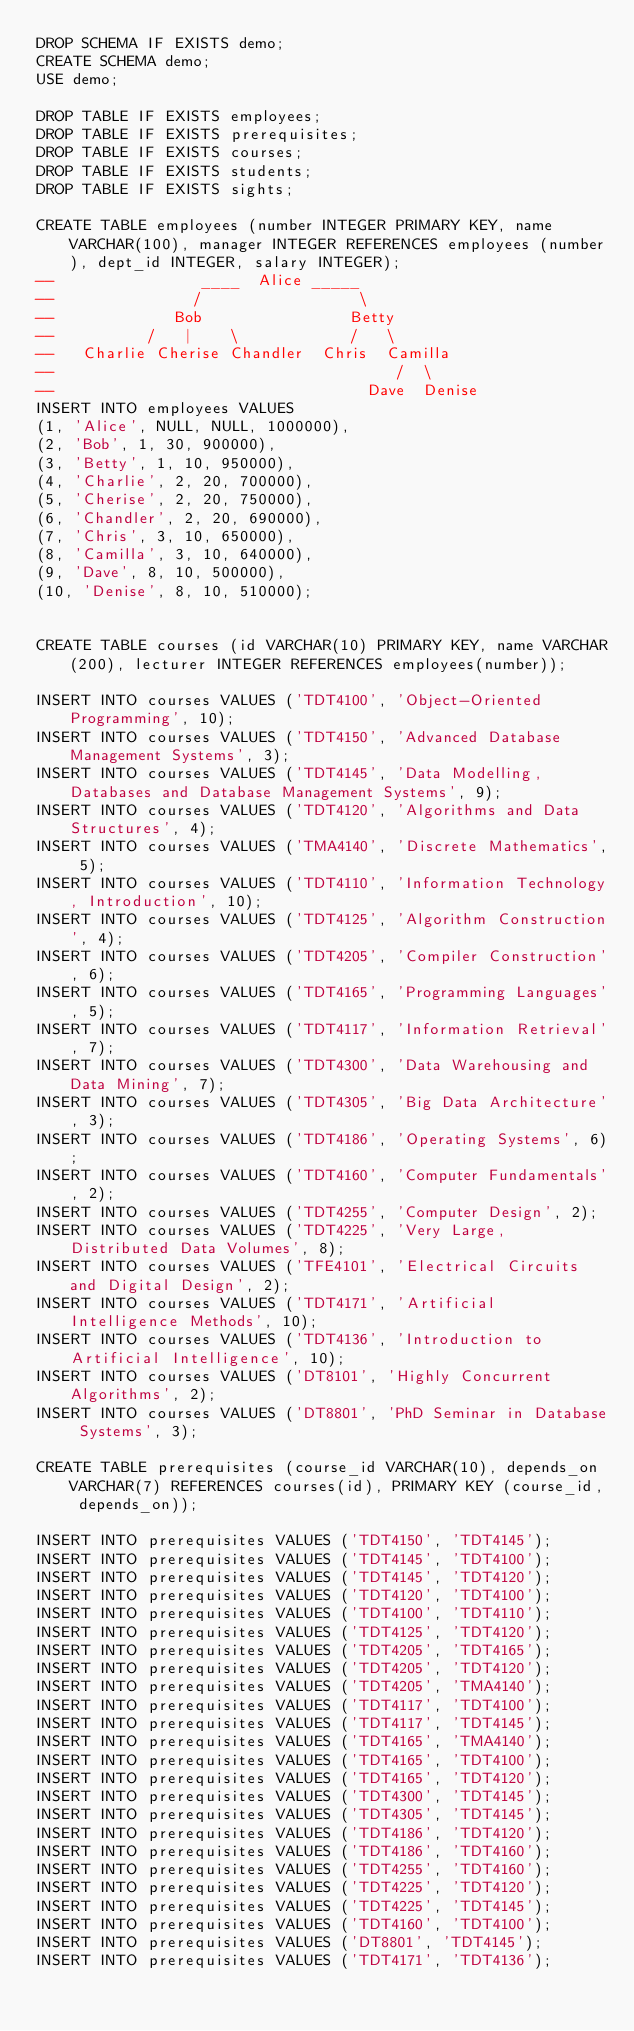Convert code to text. <code><loc_0><loc_0><loc_500><loc_500><_SQL_>DROP SCHEMA IF EXISTS demo;
CREATE SCHEMA demo;
USE demo;

DROP TABLE IF EXISTS employees;
DROP TABLE IF EXISTS prerequisites;
DROP TABLE IF EXISTS courses;
DROP TABLE IF EXISTS students;
DROP TABLE IF EXISTS sights;

CREATE TABLE employees (number INTEGER PRIMARY KEY, name VARCHAR(100), manager INTEGER REFERENCES employees (number), dept_id INTEGER, salary INTEGER);
--                ____  Alice _____
--               /                 \
--             Bob                Betty
--          /   |    \            /   \
--   Charlie Cherise Chandler  Chris  Camilla
--                                     /  \
--                                  Dave  Denise
INSERT INTO employees VALUES
(1, 'Alice', NULL, NULL, 1000000),
(2, 'Bob', 1, 30, 900000),
(3, 'Betty', 1, 10, 950000),
(4, 'Charlie', 2, 20, 700000),
(5, 'Cherise', 2, 20, 750000),
(6, 'Chandler', 2, 20, 690000),
(7, 'Chris', 3, 10, 650000),
(8, 'Camilla', 3, 10, 640000),
(9, 'Dave', 8, 10, 500000),
(10, 'Denise', 8, 10, 510000);


CREATE TABLE courses (id VARCHAR(10) PRIMARY KEY, name VARCHAR(200), lecturer INTEGER REFERENCES employees(number));

INSERT INTO courses VALUES ('TDT4100', 'Object-Oriented Programming', 10);
INSERT INTO courses VALUES ('TDT4150', 'Advanced Database Management Systems', 3);
INSERT INTO courses VALUES ('TDT4145', 'Data Modelling, Databases and Database Management Systems', 9);
INSERT INTO courses VALUES ('TDT4120', 'Algorithms and Data Structures', 4);
INSERT INTO courses VALUES ('TMA4140', 'Discrete Mathematics', 5);
INSERT INTO courses VALUES ('TDT4110', 'Information Technology, Introduction', 10);
INSERT INTO courses VALUES ('TDT4125', 'Algorithm Construction', 4);
INSERT INTO courses VALUES ('TDT4205', 'Compiler Construction', 6);
INSERT INTO courses VALUES ('TDT4165', 'Programming Languages', 5);
INSERT INTO courses VALUES ('TDT4117', 'Information Retrieval', 7);
INSERT INTO courses VALUES ('TDT4300', 'Data Warehousing and Data Mining', 7);
INSERT INTO courses VALUES ('TDT4305', 'Big Data Architecture', 3);
INSERT INTO courses VALUES ('TDT4186', 'Operating Systems', 6);
INSERT INTO courses VALUES ('TDT4160', 'Computer Fundamentals', 2);
INSERT INTO courses VALUES ('TDT4255', 'Computer Design', 2);
INSERT INTO courses VALUES ('TDT4225', 'Very Large, Distributed Data Volumes', 8);
INSERT INTO courses VALUES ('TFE4101', 'Electrical Circuits and Digital Design', 2);
INSERT INTO courses VALUES ('TDT4171', 'Artificial Intelligence Methods', 10);
INSERT INTO courses VALUES ('TDT4136', 'Introduction to Artificial Intelligence', 10);
INSERT INTO courses VALUES ('DT8101', 'Highly Concurrent Algorithms', 2);
INSERT INTO courses VALUES ('DT8801', 'PhD Seminar in Database Systems', 3);

CREATE TABLE prerequisites (course_id VARCHAR(10), depends_on VARCHAR(7) REFERENCES courses(id), PRIMARY KEY (course_id, depends_on));

INSERT INTO prerequisites VALUES ('TDT4150', 'TDT4145');
INSERT INTO prerequisites VALUES ('TDT4145', 'TDT4100');
INSERT INTO prerequisites VALUES ('TDT4145', 'TDT4120');
INSERT INTO prerequisites VALUES ('TDT4120', 'TDT4100');
INSERT INTO prerequisites VALUES ('TDT4100', 'TDT4110');
INSERT INTO prerequisites VALUES ('TDT4125', 'TDT4120');
INSERT INTO prerequisites VALUES ('TDT4205', 'TDT4165');
INSERT INTO prerequisites VALUES ('TDT4205', 'TDT4120');
INSERT INTO prerequisites VALUES ('TDT4205', 'TMA4140');
INSERT INTO prerequisites VALUES ('TDT4117', 'TDT4100');
INSERT INTO prerequisites VALUES ('TDT4117', 'TDT4145');
INSERT INTO prerequisites VALUES ('TDT4165', 'TMA4140');
INSERT INTO prerequisites VALUES ('TDT4165', 'TDT4100');
INSERT INTO prerequisites VALUES ('TDT4165', 'TDT4120');
INSERT INTO prerequisites VALUES ('TDT4300', 'TDT4145');
INSERT INTO prerequisites VALUES ('TDT4305', 'TDT4145');
INSERT INTO prerequisites VALUES ('TDT4186', 'TDT4120');
INSERT INTO prerequisites VALUES ('TDT4186', 'TDT4160');
INSERT INTO prerequisites VALUES ('TDT4255', 'TDT4160');
INSERT INTO prerequisites VALUES ('TDT4225', 'TDT4120');
INSERT INTO prerequisites VALUES ('TDT4225', 'TDT4145');
INSERT INTO prerequisites VALUES ('TDT4160', 'TDT4100');
INSERT INTO prerequisites VALUES ('DT8801', 'TDT4145');
INSERT INTO prerequisites VALUES ('TDT4171', 'TDT4136');</code> 